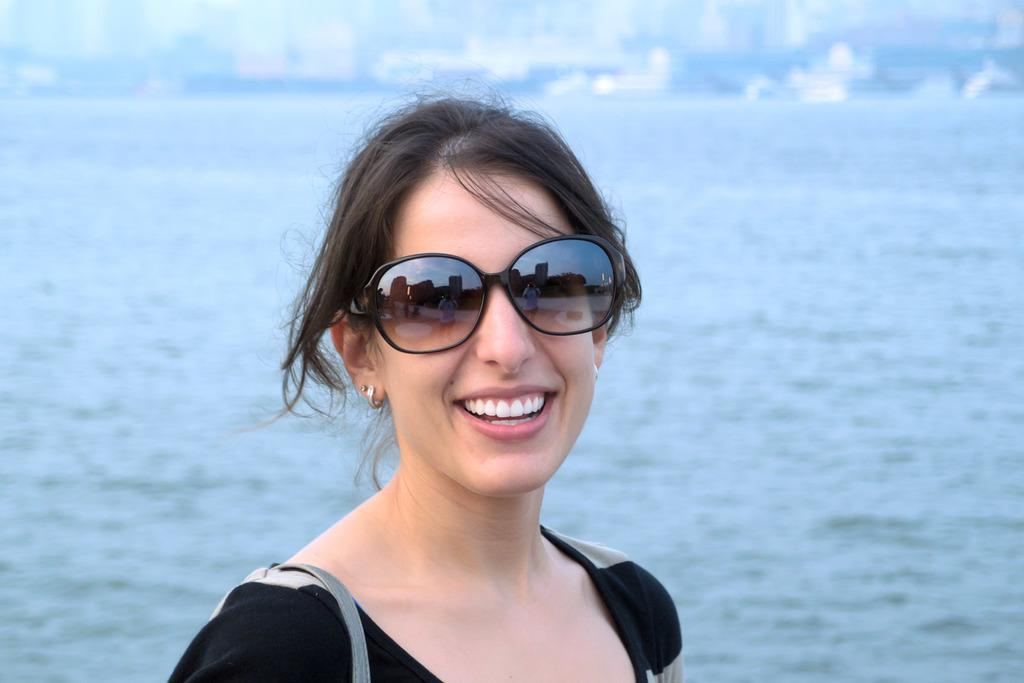Who is the main subject in the image? There is a lady in the center of the image. What is the lady doing in the image? The lady is smiling. What is the lady wearing that is unique in the image? The lady is wearing goggles. What can be seen in the background of the image? There are buildings and water visible in the background of the image. What type of government is depicted in the image? There is no government depicted in the image; it features a lady wearing goggles and smiling. What river is the lady standing next to in the image? There is no river present in the image, only water visible in the background. 